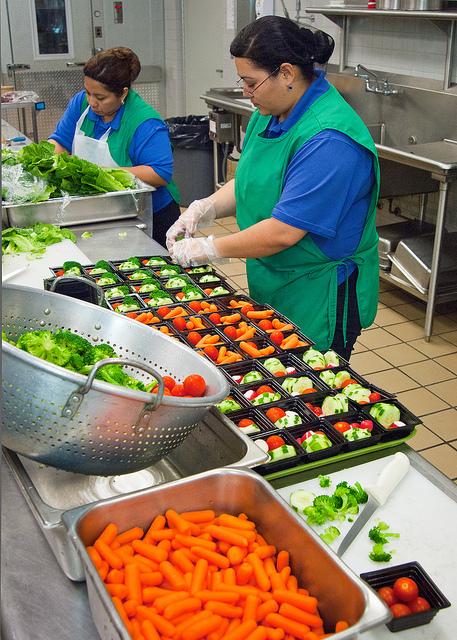Is there any meat in this image?
Give a very brief answer. No. What is in the metal tray next to the tomatoes?
Be succinct. Carrots. What type of floor are they standing on?
Write a very short answer. Tile. 